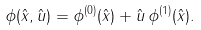<formula> <loc_0><loc_0><loc_500><loc_500>\phi ( { \hat { x } } , { \hat { u } } ) = \phi ^ { ( 0 ) } ( { \hat { x } } ) + { \hat { u } } \, \phi ^ { ( 1 ) } ( { \hat { x } } ) .</formula> 